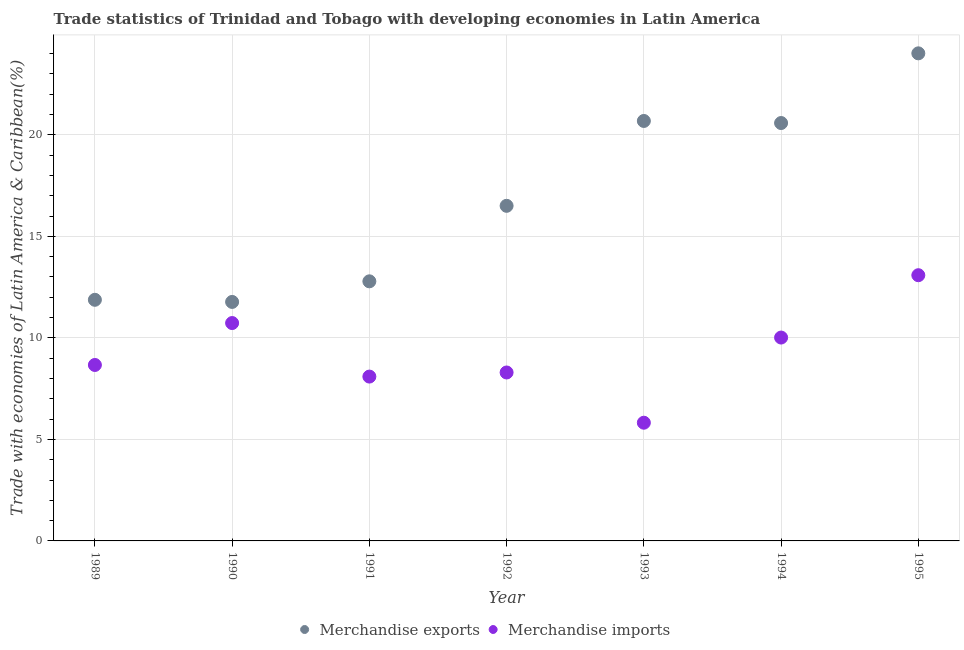What is the merchandise imports in 1990?
Your answer should be compact. 10.73. Across all years, what is the maximum merchandise exports?
Keep it short and to the point. 24.01. Across all years, what is the minimum merchandise imports?
Provide a succinct answer. 5.82. In which year was the merchandise imports maximum?
Ensure brevity in your answer.  1995. What is the total merchandise exports in the graph?
Ensure brevity in your answer.  118.21. What is the difference between the merchandise imports in 1992 and that in 1994?
Give a very brief answer. -1.72. What is the difference between the merchandise imports in 1989 and the merchandise exports in 1995?
Offer a very short reply. -15.35. What is the average merchandise exports per year?
Give a very brief answer. 16.89. In the year 1990, what is the difference between the merchandise imports and merchandise exports?
Your answer should be compact. -1.04. In how many years, is the merchandise exports greater than 19 %?
Provide a succinct answer. 3. What is the ratio of the merchandise exports in 1990 to that in 1994?
Provide a succinct answer. 0.57. Is the difference between the merchandise exports in 1989 and 1991 greater than the difference between the merchandise imports in 1989 and 1991?
Offer a very short reply. No. What is the difference between the highest and the second highest merchandise exports?
Provide a succinct answer. 3.33. What is the difference between the highest and the lowest merchandise imports?
Ensure brevity in your answer.  7.26. In how many years, is the merchandise exports greater than the average merchandise exports taken over all years?
Ensure brevity in your answer.  3. Does the merchandise exports monotonically increase over the years?
Keep it short and to the point. No. Is the merchandise imports strictly less than the merchandise exports over the years?
Offer a very short reply. Yes. How many years are there in the graph?
Make the answer very short. 7. What is the difference between two consecutive major ticks on the Y-axis?
Your answer should be very brief. 5. Are the values on the major ticks of Y-axis written in scientific E-notation?
Give a very brief answer. No. Does the graph contain grids?
Your answer should be very brief. Yes. Where does the legend appear in the graph?
Ensure brevity in your answer.  Bottom center. How many legend labels are there?
Keep it short and to the point. 2. How are the legend labels stacked?
Ensure brevity in your answer.  Horizontal. What is the title of the graph?
Make the answer very short. Trade statistics of Trinidad and Tobago with developing economies in Latin America. Does "From production" appear as one of the legend labels in the graph?
Keep it short and to the point. No. What is the label or title of the Y-axis?
Make the answer very short. Trade with economies of Latin America & Caribbean(%). What is the Trade with economies of Latin America & Caribbean(%) in Merchandise exports in 1989?
Keep it short and to the point. 11.87. What is the Trade with economies of Latin America & Caribbean(%) of Merchandise imports in 1989?
Provide a short and direct response. 8.67. What is the Trade with economies of Latin America & Caribbean(%) in Merchandise exports in 1990?
Make the answer very short. 11.77. What is the Trade with economies of Latin America & Caribbean(%) of Merchandise imports in 1990?
Ensure brevity in your answer.  10.73. What is the Trade with economies of Latin America & Caribbean(%) in Merchandise exports in 1991?
Provide a short and direct response. 12.78. What is the Trade with economies of Latin America & Caribbean(%) of Merchandise imports in 1991?
Your answer should be compact. 8.09. What is the Trade with economies of Latin America & Caribbean(%) in Merchandise exports in 1992?
Offer a terse response. 16.5. What is the Trade with economies of Latin America & Caribbean(%) in Merchandise imports in 1992?
Ensure brevity in your answer.  8.3. What is the Trade with economies of Latin America & Caribbean(%) in Merchandise exports in 1993?
Provide a succinct answer. 20.68. What is the Trade with economies of Latin America & Caribbean(%) of Merchandise imports in 1993?
Provide a short and direct response. 5.82. What is the Trade with economies of Latin America & Caribbean(%) of Merchandise exports in 1994?
Make the answer very short. 20.58. What is the Trade with economies of Latin America & Caribbean(%) of Merchandise imports in 1994?
Make the answer very short. 10.02. What is the Trade with economies of Latin America & Caribbean(%) in Merchandise exports in 1995?
Provide a succinct answer. 24.01. What is the Trade with economies of Latin America & Caribbean(%) of Merchandise imports in 1995?
Offer a terse response. 13.09. Across all years, what is the maximum Trade with economies of Latin America & Caribbean(%) of Merchandise exports?
Ensure brevity in your answer.  24.01. Across all years, what is the maximum Trade with economies of Latin America & Caribbean(%) in Merchandise imports?
Make the answer very short. 13.09. Across all years, what is the minimum Trade with economies of Latin America & Caribbean(%) in Merchandise exports?
Provide a short and direct response. 11.77. Across all years, what is the minimum Trade with economies of Latin America & Caribbean(%) in Merchandise imports?
Ensure brevity in your answer.  5.82. What is the total Trade with economies of Latin America & Caribbean(%) in Merchandise exports in the graph?
Make the answer very short. 118.21. What is the total Trade with economies of Latin America & Caribbean(%) of Merchandise imports in the graph?
Provide a short and direct response. 64.71. What is the difference between the Trade with economies of Latin America & Caribbean(%) in Merchandise exports in 1989 and that in 1990?
Your answer should be compact. 0.1. What is the difference between the Trade with economies of Latin America & Caribbean(%) of Merchandise imports in 1989 and that in 1990?
Provide a succinct answer. -2.06. What is the difference between the Trade with economies of Latin America & Caribbean(%) in Merchandise exports in 1989 and that in 1991?
Keep it short and to the point. -0.91. What is the difference between the Trade with economies of Latin America & Caribbean(%) in Merchandise imports in 1989 and that in 1991?
Provide a short and direct response. 0.57. What is the difference between the Trade with economies of Latin America & Caribbean(%) in Merchandise exports in 1989 and that in 1992?
Keep it short and to the point. -4.63. What is the difference between the Trade with economies of Latin America & Caribbean(%) of Merchandise imports in 1989 and that in 1992?
Your answer should be very brief. 0.37. What is the difference between the Trade with economies of Latin America & Caribbean(%) of Merchandise exports in 1989 and that in 1993?
Provide a succinct answer. -8.81. What is the difference between the Trade with economies of Latin America & Caribbean(%) in Merchandise imports in 1989 and that in 1993?
Make the answer very short. 2.84. What is the difference between the Trade with economies of Latin America & Caribbean(%) in Merchandise exports in 1989 and that in 1994?
Ensure brevity in your answer.  -8.71. What is the difference between the Trade with economies of Latin America & Caribbean(%) in Merchandise imports in 1989 and that in 1994?
Keep it short and to the point. -1.35. What is the difference between the Trade with economies of Latin America & Caribbean(%) in Merchandise exports in 1989 and that in 1995?
Make the answer very short. -12.14. What is the difference between the Trade with economies of Latin America & Caribbean(%) in Merchandise imports in 1989 and that in 1995?
Provide a short and direct response. -4.42. What is the difference between the Trade with economies of Latin America & Caribbean(%) in Merchandise exports in 1990 and that in 1991?
Ensure brevity in your answer.  -1.01. What is the difference between the Trade with economies of Latin America & Caribbean(%) of Merchandise imports in 1990 and that in 1991?
Offer a very short reply. 2.64. What is the difference between the Trade with economies of Latin America & Caribbean(%) in Merchandise exports in 1990 and that in 1992?
Make the answer very short. -4.73. What is the difference between the Trade with economies of Latin America & Caribbean(%) in Merchandise imports in 1990 and that in 1992?
Your answer should be compact. 2.43. What is the difference between the Trade with economies of Latin America & Caribbean(%) of Merchandise exports in 1990 and that in 1993?
Keep it short and to the point. -8.91. What is the difference between the Trade with economies of Latin America & Caribbean(%) of Merchandise imports in 1990 and that in 1993?
Offer a terse response. 4.91. What is the difference between the Trade with economies of Latin America & Caribbean(%) in Merchandise exports in 1990 and that in 1994?
Your answer should be very brief. -8.81. What is the difference between the Trade with economies of Latin America & Caribbean(%) in Merchandise imports in 1990 and that in 1994?
Provide a succinct answer. 0.71. What is the difference between the Trade with economies of Latin America & Caribbean(%) in Merchandise exports in 1990 and that in 1995?
Your answer should be very brief. -12.24. What is the difference between the Trade with economies of Latin America & Caribbean(%) of Merchandise imports in 1990 and that in 1995?
Your answer should be compact. -2.36. What is the difference between the Trade with economies of Latin America & Caribbean(%) of Merchandise exports in 1991 and that in 1992?
Offer a very short reply. -3.72. What is the difference between the Trade with economies of Latin America & Caribbean(%) in Merchandise imports in 1991 and that in 1992?
Your response must be concise. -0.2. What is the difference between the Trade with economies of Latin America & Caribbean(%) of Merchandise exports in 1991 and that in 1993?
Provide a succinct answer. -7.9. What is the difference between the Trade with economies of Latin America & Caribbean(%) of Merchandise imports in 1991 and that in 1993?
Provide a short and direct response. 2.27. What is the difference between the Trade with economies of Latin America & Caribbean(%) in Merchandise exports in 1991 and that in 1994?
Offer a terse response. -7.8. What is the difference between the Trade with economies of Latin America & Caribbean(%) in Merchandise imports in 1991 and that in 1994?
Your response must be concise. -1.92. What is the difference between the Trade with economies of Latin America & Caribbean(%) in Merchandise exports in 1991 and that in 1995?
Offer a very short reply. -11.23. What is the difference between the Trade with economies of Latin America & Caribbean(%) of Merchandise imports in 1991 and that in 1995?
Your response must be concise. -4.99. What is the difference between the Trade with economies of Latin America & Caribbean(%) in Merchandise exports in 1992 and that in 1993?
Ensure brevity in your answer.  -4.18. What is the difference between the Trade with economies of Latin America & Caribbean(%) in Merchandise imports in 1992 and that in 1993?
Ensure brevity in your answer.  2.47. What is the difference between the Trade with economies of Latin America & Caribbean(%) in Merchandise exports in 1992 and that in 1994?
Make the answer very short. -4.08. What is the difference between the Trade with economies of Latin America & Caribbean(%) of Merchandise imports in 1992 and that in 1994?
Your response must be concise. -1.72. What is the difference between the Trade with economies of Latin America & Caribbean(%) in Merchandise exports in 1992 and that in 1995?
Give a very brief answer. -7.51. What is the difference between the Trade with economies of Latin America & Caribbean(%) of Merchandise imports in 1992 and that in 1995?
Your response must be concise. -4.79. What is the difference between the Trade with economies of Latin America & Caribbean(%) in Merchandise exports in 1993 and that in 1994?
Give a very brief answer. 0.1. What is the difference between the Trade with economies of Latin America & Caribbean(%) in Merchandise imports in 1993 and that in 1994?
Keep it short and to the point. -4.19. What is the difference between the Trade with economies of Latin America & Caribbean(%) in Merchandise exports in 1993 and that in 1995?
Your answer should be compact. -3.33. What is the difference between the Trade with economies of Latin America & Caribbean(%) of Merchandise imports in 1993 and that in 1995?
Give a very brief answer. -7.26. What is the difference between the Trade with economies of Latin America & Caribbean(%) in Merchandise exports in 1994 and that in 1995?
Give a very brief answer. -3.43. What is the difference between the Trade with economies of Latin America & Caribbean(%) in Merchandise imports in 1994 and that in 1995?
Give a very brief answer. -3.07. What is the difference between the Trade with economies of Latin America & Caribbean(%) in Merchandise exports in 1989 and the Trade with economies of Latin America & Caribbean(%) in Merchandise imports in 1990?
Provide a short and direct response. 1.14. What is the difference between the Trade with economies of Latin America & Caribbean(%) of Merchandise exports in 1989 and the Trade with economies of Latin America & Caribbean(%) of Merchandise imports in 1991?
Offer a very short reply. 3.78. What is the difference between the Trade with economies of Latin America & Caribbean(%) of Merchandise exports in 1989 and the Trade with economies of Latin America & Caribbean(%) of Merchandise imports in 1992?
Give a very brief answer. 3.58. What is the difference between the Trade with economies of Latin America & Caribbean(%) of Merchandise exports in 1989 and the Trade with economies of Latin America & Caribbean(%) of Merchandise imports in 1993?
Your answer should be compact. 6.05. What is the difference between the Trade with economies of Latin America & Caribbean(%) in Merchandise exports in 1989 and the Trade with economies of Latin America & Caribbean(%) in Merchandise imports in 1994?
Your response must be concise. 1.86. What is the difference between the Trade with economies of Latin America & Caribbean(%) of Merchandise exports in 1989 and the Trade with economies of Latin America & Caribbean(%) of Merchandise imports in 1995?
Your response must be concise. -1.21. What is the difference between the Trade with economies of Latin America & Caribbean(%) of Merchandise exports in 1990 and the Trade with economies of Latin America & Caribbean(%) of Merchandise imports in 1991?
Your response must be concise. 3.68. What is the difference between the Trade with economies of Latin America & Caribbean(%) in Merchandise exports in 1990 and the Trade with economies of Latin America & Caribbean(%) in Merchandise imports in 1992?
Keep it short and to the point. 3.47. What is the difference between the Trade with economies of Latin America & Caribbean(%) in Merchandise exports in 1990 and the Trade with economies of Latin America & Caribbean(%) in Merchandise imports in 1993?
Offer a very short reply. 5.95. What is the difference between the Trade with economies of Latin America & Caribbean(%) in Merchandise exports in 1990 and the Trade with economies of Latin America & Caribbean(%) in Merchandise imports in 1994?
Provide a succinct answer. 1.75. What is the difference between the Trade with economies of Latin America & Caribbean(%) in Merchandise exports in 1990 and the Trade with economies of Latin America & Caribbean(%) in Merchandise imports in 1995?
Provide a short and direct response. -1.32. What is the difference between the Trade with economies of Latin America & Caribbean(%) in Merchandise exports in 1991 and the Trade with economies of Latin America & Caribbean(%) in Merchandise imports in 1992?
Your response must be concise. 4.49. What is the difference between the Trade with economies of Latin America & Caribbean(%) of Merchandise exports in 1991 and the Trade with economies of Latin America & Caribbean(%) of Merchandise imports in 1993?
Your response must be concise. 6.96. What is the difference between the Trade with economies of Latin America & Caribbean(%) in Merchandise exports in 1991 and the Trade with economies of Latin America & Caribbean(%) in Merchandise imports in 1994?
Make the answer very short. 2.77. What is the difference between the Trade with economies of Latin America & Caribbean(%) in Merchandise exports in 1991 and the Trade with economies of Latin America & Caribbean(%) in Merchandise imports in 1995?
Your answer should be compact. -0.3. What is the difference between the Trade with economies of Latin America & Caribbean(%) of Merchandise exports in 1992 and the Trade with economies of Latin America & Caribbean(%) of Merchandise imports in 1993?
Keep it short and to the point. 10.68. What is the difference between the Trade with economies of Latin America & Caribbean(%) in Merchandise exports in 1992 and the Trade with economies of Latin America & Caribbean(%) in Merchandise imports in 1994?
Offer a very short reply. 6.49. What is the difference between the Trade with economies of Latin America & Caribbean(%) of Merchandise exports in 1992 and the Trade with economies of Latin America & Caribbean(%) of Merchandise imports in 1995?
Your answer should be very brief. 3.42. What is the difference between the Trade with economies of Latin America & Caribbean(%) in Merchandise exports in 1993 and the Trade with economies of Latin America & Caribbean(%) in Merchandise imports in 1994?
Your answer should be compact. 10.67. What is the difference between the Trade with economies of Latin America & Caribbean(%) of Merchandise exports in 1993 and the Trade with economies of Latin America & Caribbean(%) of Merchandise imports in 1995?
Make the answer very short. 7.6. What is the difference between the Trade with economies of Latin America & Caribbean(%) of Merchandise exports in 1994 and the Trade with economies of Latin America & Caribbean(%) of Merchandise imports in 1995?
Offer a terse response. 7.49. What is the average Trade with economies of Latin America & Caribbean(%) in Merchandise exports per year?
Give a very brief answer. 16.89. What is the average Trade with economies of Latin America & Caribbean(%) of Merchandise imports per year?
Provide a succinct answer. 9.24. In the year 1989, what is the difference between the Trade with economies of Latin America & Caribbean(%) of Merchandise exports and Trade with economies of Latin America & Caribbean(%) of Merchandise imports?
Provide a succinct answer. 3.21. In the year 1990, what is the difference between the Trade with economies of Latin America & Caribbean(%) in Merchandise exports and Trade with economies of Latin America & Caribbean(%) in Merchandise imports?
Your answer should be very brief. 1.04. In the year 1991, what is the difference between the Trade with economies of Latin America & Caribbean(%) of Merchandise exports and Trade with economies of Latin America & Caribbean(%) of Merchandise imports?
Provide a succinct answer. 4.69. In the year 1992, what is the difference between the Trade with economies of Latin America & Caribbean(%) in Merchandise exports and Trade with economies of Latin America & Caribbean(%) in Merchandise imports?
Make the answer very short. 8.21. In the year 1993, what is the difference between the Trade with economies of Latin America & Caribbean(%) of Merchandise exports and Trade with economies of Latin America & Caribbean(%) of Merchandise imports?
Keep it short and to the point. 14.86. In the year 1994, what is the difference between the Trade with economies of Latin America & Caribbean(%) of Merchandise exports and Trade with economies of Latin America & Caribbean(%) of Merchandise imports?
Ensure brevity in your answer.  10.56. In the year 1995, what is the difference between the Trade with economies of Latin America & Caribbean(%) of Merchandise exports and Trade with economies of Latin America & Caribbean(%) of Merchandise imports?
Your answer should be compact. 10.93. What is the ratio of the Trade with economies of Latin America & Caribbean(%) in Merchandise exports in 1989 to that in 1990?
Give a very brief answer. 1.01. What is the ratio of the Trade with economies of Latin America & Caribbean(%) in Merchandise imports in 1989 to that in 1990?
Your answer should be compact. 0.81. What is the ratio of the Trade with economies of Latin America & Caribbean(%) in Merchandise exports in 1989 to that in 1991?
Your answer should be very brief. 0.93. What is the ratio of the Trade with economies of Latin America & Caribbean(%) in Merchandise imports in 1989 to that in 1991?
Provide a short and direct response. 1.07. What is the ratio of the Trade with economies of Latin America & Caribbean(%) in Merchandise exports in 1989 to that in 1992?
Your answer should be compact. 0.72. What is the ratio of the Trade with economies of Latin America & Caribbean(%) of Merchandise imports in 1989 to that in 1992?
Make the answer very short. 1.04. What is the ratio of the Trade with economies of Latin America & Caribbean(%) of Merchandise exports in 1989 to that in 1993?
Keep it short and to the point. 0.57. What is the ratio of the Trade with economies of Latin America & Caribbean(%) in Merchandise imports in 1989 to that in 1993?
Provide a succinct answer. 1.49. What is the ratio of the Trade with economies of Latin America & Caribbean(%) in Merchandise exports in 1989 to that in 1994?
Your response must be concise. 0.58. What is the ratio of the Trade with economies of Latin America & Caribbean(%) of Merchandise imports in 1989 to that in 1994?
Make the answer very short. 0.87. What is the ratio of the Trade with economies of Latin America & Caribbean(%) in Merchandise exports in 1989 to that in 1995?
Your answer should be very brief. 0.49. What is the ratio of the Trade with economies of Latin America & Caribbean(%) in Merchandise imports in 1989 to that in 1995?
Keep it short and to the point. 0.66. What is the ratio of the Trade with economies of Latin America & Caribbean(%) of Merchandise exports in 1990 to that in 1991?
Make the answer very short. 0.92. What is the ratio of the Trade with economies of Latin America & Caribbean(%) of Merchandise imports in 1990 to that in 1991?
Provide a succinct answer. 1.33. What is the ratio of the Trade with economies of Latin America & Caribbean(%) in Merchandise exports in 1990 to that in 1992?
Keep it short and to the point. 0.71. What is the ratio of the Trade with economies of Latin America & Caribbean(%) of Merchandise imports in 1990 to that in 1992?
Your response must be concise. 1.29. What is the ratio of the Trade with economies of Latin America & Caribbean(%) of Merchandise exports in 1990 to that in 1993?
Your answer should be very brief. 0.57. What is the ratio of the Trade with economies of Latin America & Caribbean(%) of Merchandise imports in 1990 to that in 1993?
Your answer should be compact. 1.84. What is the ratio of the Trade with economies of Latin America & Caribbean(%) in Merchandise exports in 1990 to that in 1994?
Provide a short and direct response. 0.57. What is the ratio of the Trade with economies of Latin America & Caribbean(%) of Merchandise imports in 1990 to that in 1994?
Your answer should be very brief. 1.07. What is the ratio of the Trade with economies of Latin America & Caribbean(%) in Merchandise exports in 1990 to that in 1995?
Ensure brevity in your answer.  0.49. What is the ratio of the Trade with economies of Latin America & Caribbean(%) of Merchandise imports in 1990 to that in 1995?
Offer a very short reply. 0.82. What is the ratio of the Trade with economies of Latin America & Caribbean(%) in Merchandise exports in 1991 to that in 1992?
Give a very brief answer. 0.77. What is the ratio of the Trade with economies of Latin America & Caribbean(%) of Merchandise imports in 1991 to that in 1992?
Make the answer very short. 0.98. What is the ratio of the Trade with economies of Latin America & Caribbean(%) in Merchandise exports in 1991 to that in 1993?
Keep it short and to the point. 0.62. What is the ratio of the Trade with economies of Latin America & Caribbean(%) in Merchandise imports in 1991 to that in 1993?
Provide a short and direct response. 1.39. What is the ratio of the Trade with economies of Latin America & Caribbean(%) in Merchandise exports in 1991 to that in 1994?
Ensure brevity in your answer.  0.62. What is the ratio of the Trade with economies of Latin America & Caribbean(%) in Merchandise imports in 1991 to that in 1994?
Your answer should be compact. 0.81. What is the ratio of the Trade with economies of Latin America & Caribbean(%) of Merchandise exports in 1991 to that in 1995?
Keep it short and to the point. 0.53. What is the ratio of the Trade with economies of Latin America & Caribbean(%) in Merchandise imports in 1991 to that in 1995?
Your answer should be compact. 0.62. What is the ratio of the Trade with economies of Latin America & Caribbean(%) in Merchandise exports in 1992 to that in 1993?
Make the answer very short. 0.8. What is the ratio of the Trade with economies of Latin America & Caribbean(%) in Merchandise imports in 1992 to that in 1993?
Offer a terse response. 1.43. What is the ratio of the Trade with economies of Latin America & Caribbean(%) of Merchandise exports in 1992 to that in 1994?
Offer a very short reply. 0.8. What is the ratio of the Trade with economies of Latin America & Caribbean(%) in Merchandise imports in 1992 to that in 1994?
Ensure brevity in your answer.  0.83. What is the ratio of the Trade with economies of Latin America & Caribbean(%) in Merchandise exports in 1992 to that in 1995?
Offer a terse response. 0.69. What is the ratio of the Trade with economies of Latin America & Caribbean(%) in Merchandise imports in 1992 to that in 1995?
Keep it short and to the point. 0.63. What is the ratio of the Trade with economies of Latin America & Caribbean(%) in Merchandise imports in 1993 to that in 1994?
Offer a very short reply. 0.58. What is the ratio of the Trade with economies of Latin America & Caribbean(%) in Merchandise exports in 1993 to that in 1995?
Keep it short and to the point. 0.86. What is the ratio of the Trade with economies of Latin America & Caribbean(%) of Merchandise imports in 1993 to that in 1995?
Offer a very short reply. 0.44. What is the ratio of the Trade with economies of Latin America & Caribbean(%) of Merchandise imports in 1994 to that in 1995?
Offer a terse response. 0.77. What is the difference between the highest and the second highest Trade with economies of Latin America & Caribbean(%) of Merchandise exports?
Offer a terse response. 3.33. What is the difference between the highest and the second highest Trade with economies of Latin America & Caribbean(%) of Merchandise imports?
Provide a succinct answer. 2.36. What is the difference between the highest and the lowest Trade with economies of Latin America & Caribbean(%) of Merchandise exports?
Give a very brief answer. 12.24. What is the difference between the highest and the lowest Trade with economies of Latin America & Caribbean(%) of Merchandise imports?
Your response must be concise. 7.26. 